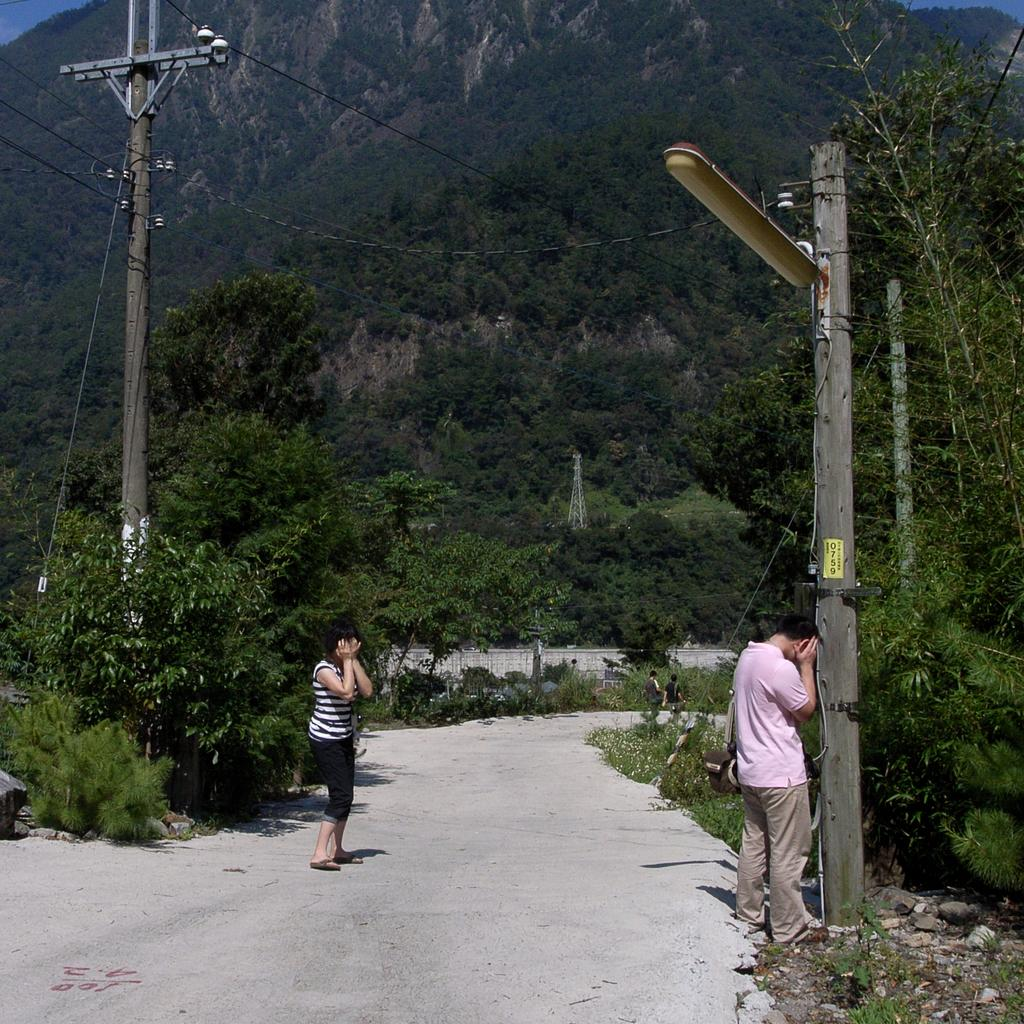How many people are in the image? There are two persons in the image. What are the persons doing in the image? The persons have their eyes closed in the image. Where are the persons located in the image? The persons are on a road in the image. What can be seen in the background of the image? There is a mountain, trees, and plants in the background of the image. What type of instrument is the person playing in the image? There is no instrument present in the image; the persons have their eyes closed and are not playing any instrument. What is the weather like in the image? The provided facts do not mention the weather, so we cannot determine the weather from the image. 